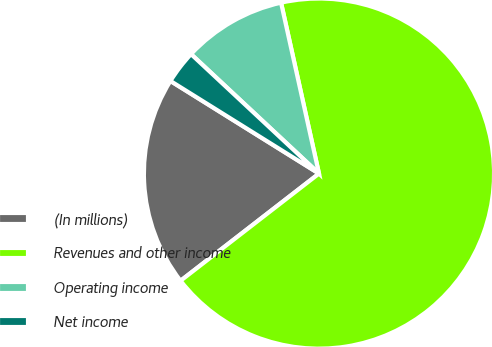Convert chart to OTSL. <chart><loc_0><loc_0><loc_500><loc_500><pie_chart><fcel>(In millions)<fcel>Revenues and other income<fcel>Operating income<fcel>Net income<nl><fcel>19.36%<fcel>67.99%<fcel>9.57%<fcel>3.08%<nl></chart> 